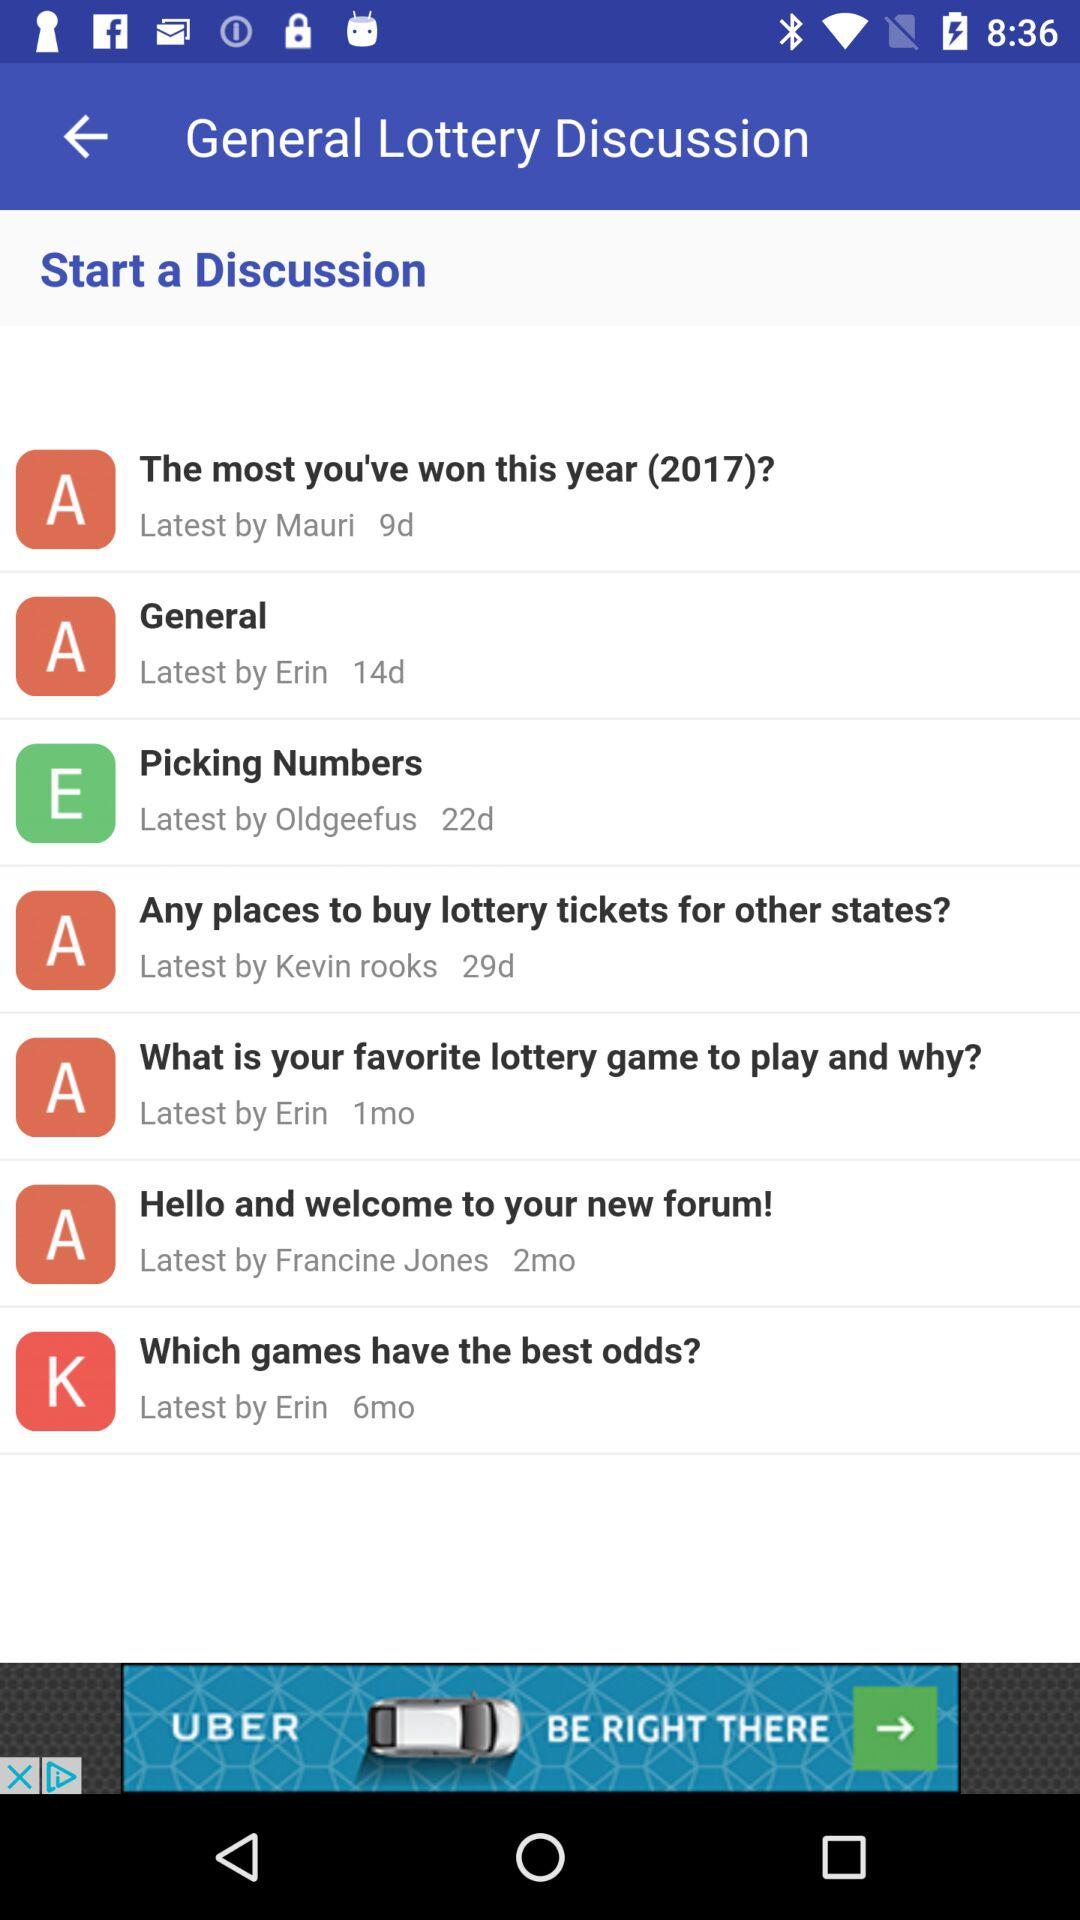By Erin, which discussion has been done? The discussions that have been done by Erin are "General", "What is your favorite lottery game to play and why?" and "Which games have the best odds?". 